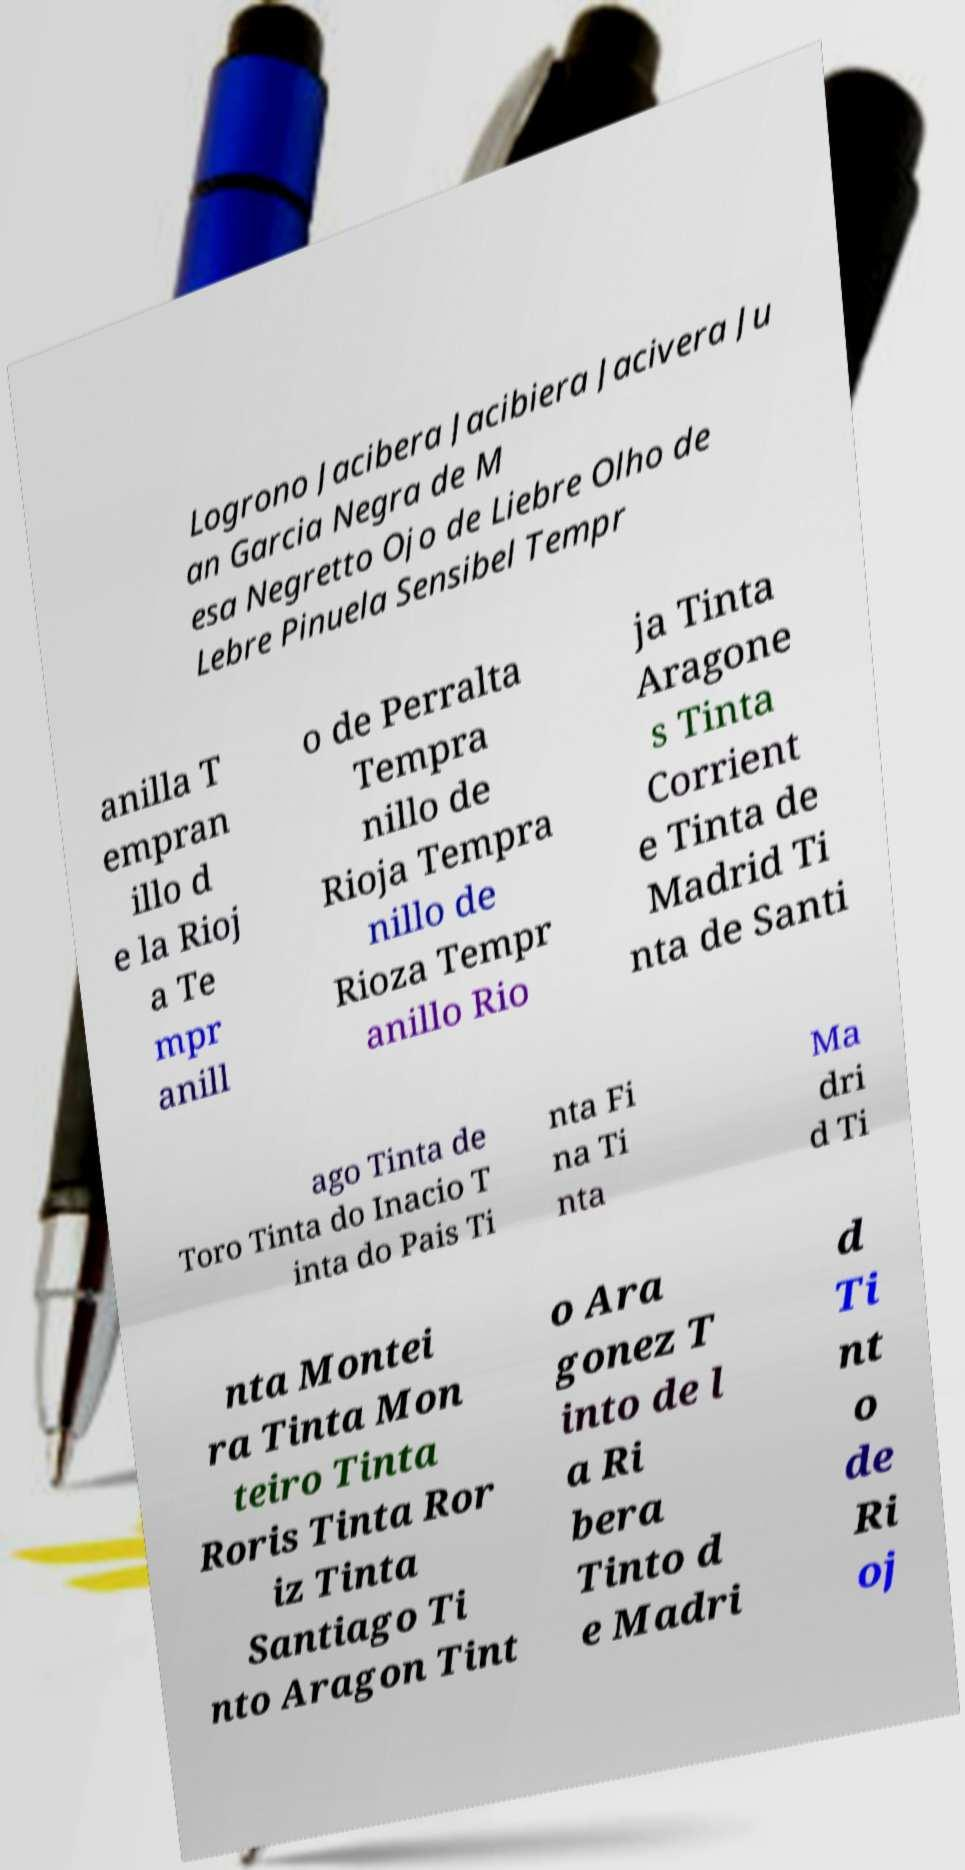Could you extract and type out the text from this image? Logrono Jacibera Jacibiera Jacivera Ju an Garcia Negra de M esa Negretto Ojo de Liebre Olho de Lebre Pinuela Sensibel Tempr anilla T empran illo d e la Rioj a Te mpr anill o de Perralta Tempra nillo de Rioja Tempra nillo de Rioza Tempr anillo Rio ja Tinta Aragone s Tinta Corrient e Tinta de Madrid Ti nta de Santi ago Tinta de Toro Tinta do Inacio T inta do Pais Ti nta Fi na Ti nta Ma dri d Ti nta Montei ra Tinta Mon teiro Tinta Roris Tinta Ror iz Tinta Santiago Ti nto Aragon Tint o Ara gonez T into de l a Ri bera Tinto d e Madri d Ti nt o de Ri oj 